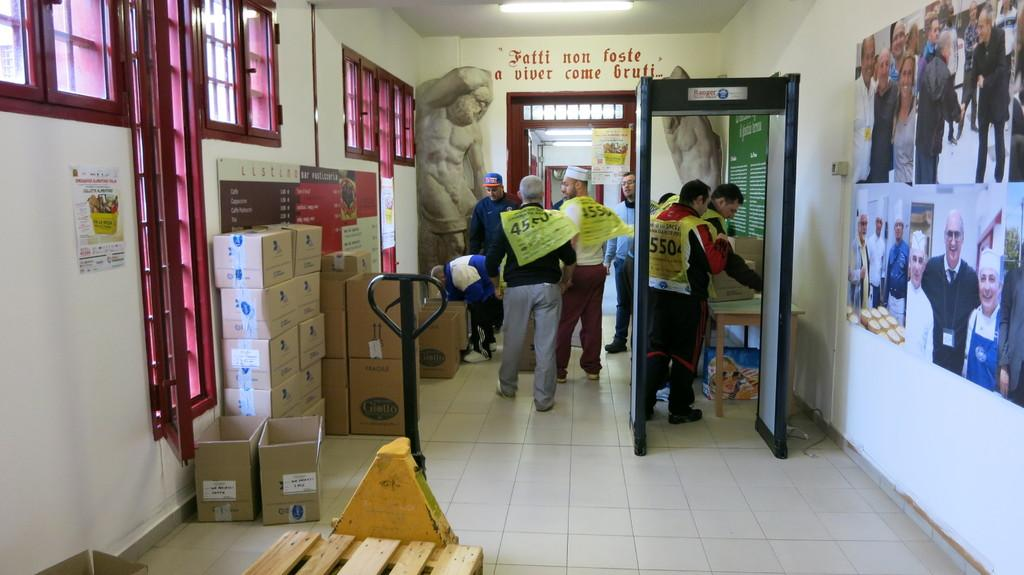What type of openings can be seen in the image? There are windows in the image. What items are present in the image that are typically used for storage or transportation? There are boxes and persons carrying bags on their shoulders in the image. What type of furniture is visible in the image? There is a wooden table in the image. What type of artwork is present in the image? There are sculptures and pictures on the walls in the image. What can be seen written on a wall in the image? There is a text written on a wall in the image. What other objects can be seen in the image besides the ones mentioned? There are other objects in the image. Can you tell me how many crackers are on the wooden table in the image? There is no mention of crackers in the image, so it is not possible to determine their presence or quantity. What type of map is hanging on the wall in the image? There is no mention of a map in the image, so it is not possible to determine its presence or type. 